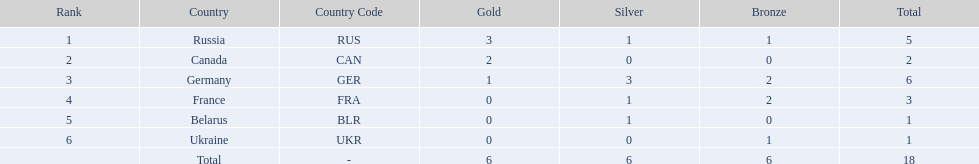Which country won more total medals than tue french, but less than the germans in the 1994 winter olympic biathlon? Russia. 